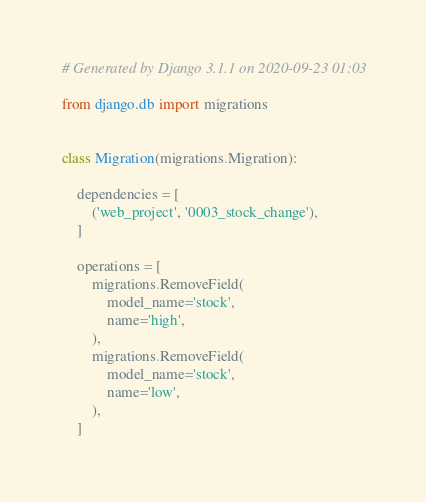Convert code to text. <code><loc_0><loc_0><loc_500><loc_500><_Python_># Generated by Django 3.1.1 on 2020-09-23 01:03

from django.db import migrations


class Migration(migrations.Migration):

    dependencies = [
        ('web_project', '0003_stock_change'),
    ]

    operations = [
        migrations.RemoveField(
            model_name='stock',
            name='high',
        ),
        migrations.RemoveField(
            model_name='stock',
            name='low',
        ),
    ]
</code> 